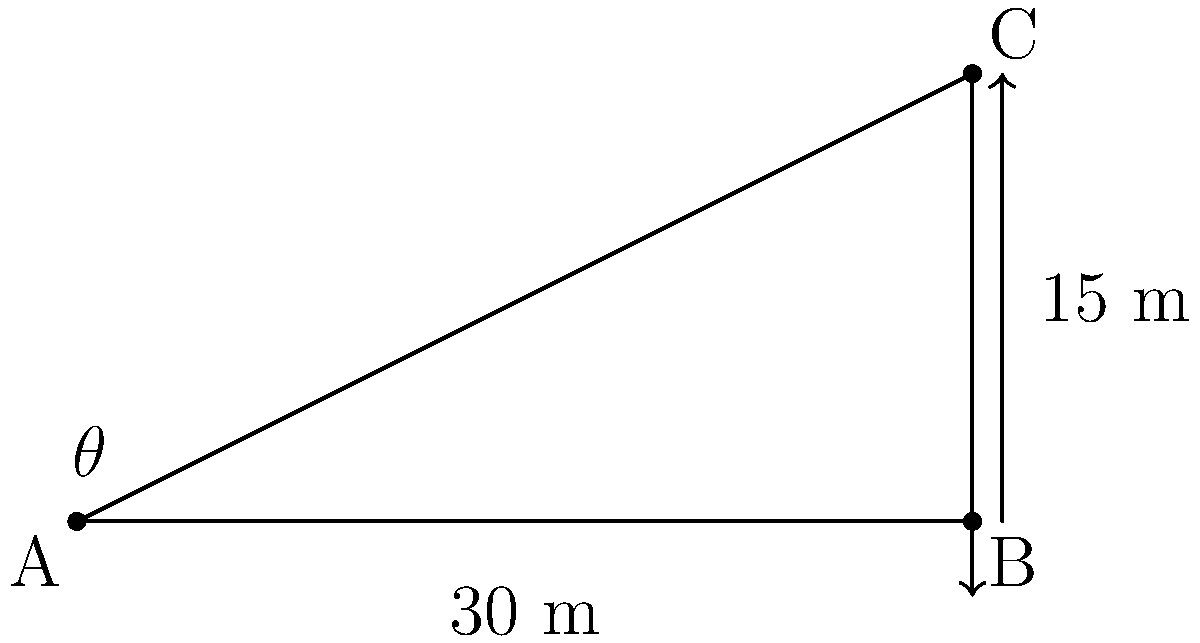As an Instagrammer looking to boost your engagement, you decide to take a photo of a tall billboard from a distance. You're standing 30 meters away from the base of the billboard, and the top of the billboard is 15 meters high. What is the angle of elevation (θ) from your eye level to the top of the billboard? (Assume your eye level is at the same height as the base of the billboard) Let's approach this step-by-step:

1) First, we identify that we have a right triangle. The base of the triangle is the distance from you to the billboard (30 m), and the height is the height of the billboard (15 m).

2) We need to find the angle θ, which is the angle of elevation.

3) In this right triangle, we know:
   - The opposite side (O) = 15 m
   - The adjacent side (A) = 30 m

4) To find the angle using these two sides, we should use the tangent function:

   $$\tan(\theta) = \frac{\text{Opposite}}{\text{Adjacent}} = \frac{O}{A}$$

5) Plugging in our values:

   $$\tan(\theta) = \frac{15}{30} = \frac{1}{2} = 0.5$$

6) To find θ, we need to use the inverse tangent (arctan or tan^(-1)):

   $$\theta = \tan^{-1}(0.5)$$

7) Using a calculator or trigonometric tables:

   $$\theta ≈ 26.57°$$

This angle would help you capture the perfect shot for maximum engagement on your Instagram post!
Answer: $26.57°$ 